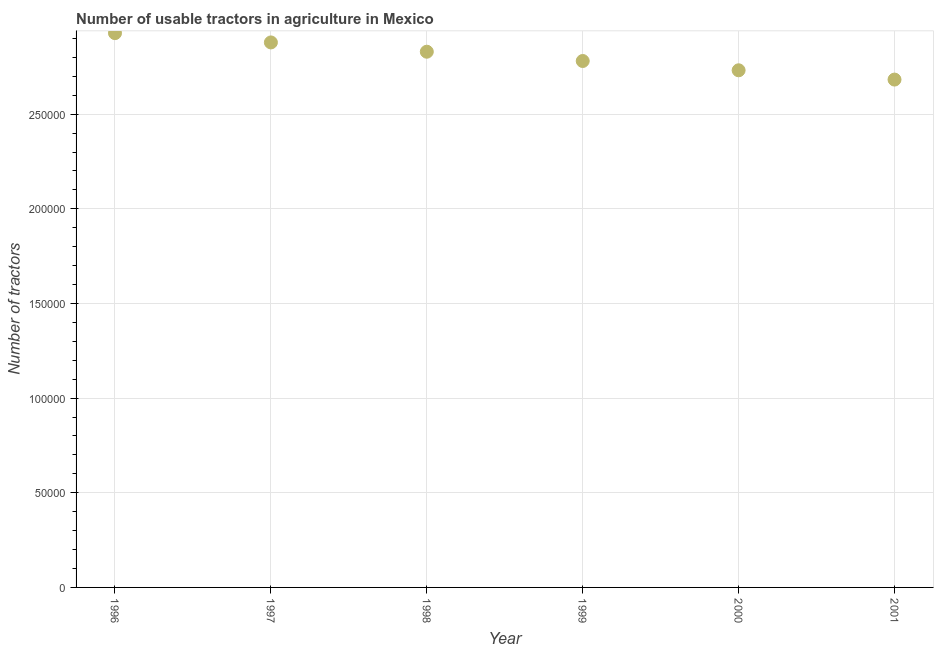What is the number of tractors in 2001?
Your answer should be very brief. 2.68e+05. Across all years, what is the maximum number of tractors?
Make the answer very short. 2.93e+05. Across all years, what is the minimum number of tractors?
Make the answer very short. 2.68e+05. In which year was the number of tractors maximum?
Keep it short and to the point. 1996. In which year was the number of tractors minimum?
Provide a short and direct response. 2001. What is the sum of the number of tractors?
Offer a terse response. 1.68e+06. What is the difference between the number of tractors in 1997 and 1999?
Offer a very short reply. 9810. What is the average number of tractors per year?
Your response must be concise. 2.81e+05. What is the median number of tractors?
Give a very brief answer. 2.81e+05. What is the ratio of the number of tractors in 2000 to that in 2001?
Provide a succinct answer. 1.02. Is the number of tractors in 1999 less than that in 2001?
Offer a terse response. No. Is the difference between the number of tractors in 1998 and 1999 greater than the difference between any two years?
Make the answer very short. No. What is the difference between the highest and the second highest number of tractors?
Make the answer very short. 4905. Is the sum of the number of tractors in 1996 and 1997 greater than the maximum number of tractors across all years?
Your answer should be compact. Yes. What is the difference between the highest and the lowest number of tractors?
Your answer should be very brief. 2.45e+04. Does the number of tractors monotonically increase over the years?
Offer a very short reply. No. How many dotlines are there?
Your response must be concise. 1. How many years are there in the graph?
Give a very brief answer. 6. What is the difference between two consecutive major ticks on the Y-axis?
Your response must be concise. 5.00e+04. Are the values on the major ticks of Y-axis written in scientific E-notation?
Your answer should be very brief. No. Does the graph contain any zero values?
Offer a very short reply. No. What is the title of the graph?
Offer a very short reply. Number of usable tractors in agriculture in Mexico. What is the label or title of the Y-axis?
Keep it short and to the point. Number of tractors. What is the Number of tractors in 1996?
Your response must be concise. 2.93e+05. What is the Number of tractors in 1997?
Provide a succinct answer. 2.88e+05. What is the Number of tractors in 1998?
Offer a terse response. 2.83e+05. What is the Number of tractors in 1999?
Give a very brief answer. 2.78e+05. What is the Number of tractors in 2000?
Give a very brief answer. 2.73e+05. What is the Number of tractors in 2001?
Provide a short and direct response. 2.68e+05. What is the difference between the Number of tractors in 1996 and 1997?
Provide a succinct answer. 4905. What is the difference between the Number of tractors in 1996 and 1998?
Your answer should be very brief. 9810. What is the difference between the Number of tractors in 1996 and 1999?
Make the answer very short. 1.47e+04. What is the difference between the Number of tractors in 1996 and 2000?
Your response must be concise. 1.96e+04. What is the difference between the Number of tractors in 1996 and 2001?
Ensure brevity in your answer.  2.45e+04. What is the difference between the Number of tractors in 1997 and 1998?
Ensure brevity in your answer.  4905. What is the difference between the Number of tractors in 1997 and 1999?
Provide a succinct answer. 9810. What is the difference between the Number of tractors in 1997 and 2000?
Your response must be concise. 1.47e+04. What is the difference between the Number of tractors in 1997 and 2001?
Your answer should be compact. 1.96e+04. What is the difference between the Number of tractors in 1998 and 1999?
Offer a terse response. 4905. What is the difference between the Number of tractors in 1998 and 2000?
Keep it short and to the point. 9811. What is the difference between the Number of tractors in 1998 and 2001?
Provide a short and direct response. 1.47e+04. What is the difference between the Number of tractors in 1999 and 2000?
Provide a short and direct response. 4906. What is the difference between the Number of tractors in 1999 and 2001?
Ensure brevity in your answer.  9811. What is the difference between the Number of tractors in 2000 and 2001?
Your answer should be compact. 4905. What is the ratio of the Number of tractors in 1996 to that in 1997?
Offer a terse response. 1.02. What is the ratio of the Number of tractors in 1996 to that in 1998?
Offer a terse response. 1.03. What is the ratio of the Number of tractors in 1996 to that in 1999?
Provide a short and direct response. 1.05. What is the ratio of the Number of tractors in 1996 to that in 2000?
Keep it short and to the point. 1.07. What is the ratio of the Number of tractors in 1996 to that in 2001?
Your answer should be very brief. 1.09. What is the ratio of the Number of tractors in 1997 to that in 1999?
Ensure brevity in your answer.  1.03. What is the ratio of the Number of tractors in 1997 to that in 2000?
Ensure brevity in your answer.  1.05. What is the ratio of the Number of tractors in 1997 to that in 2001?
Give a very brief answer. 1.07. What is the ratio of the Number of tractors in 1998 to that in 2000?
Keep it short and to the point. 1.04. What is the ratio of the Number of tractors in 1998 to that in 2001?
Offer a terse response. 1.05. What is the ratio of the Number of tractors in 1999 to that in 2000?
Give a very brief answer. 1.02. What is the ratio of the Number of tractors in 1999 to that in 2001?
Your answer should be very brief. 1.04. What is the ratio of the Number of tractors in 2000 to that in 2001?
Keep it short and to the point. 1.02. 